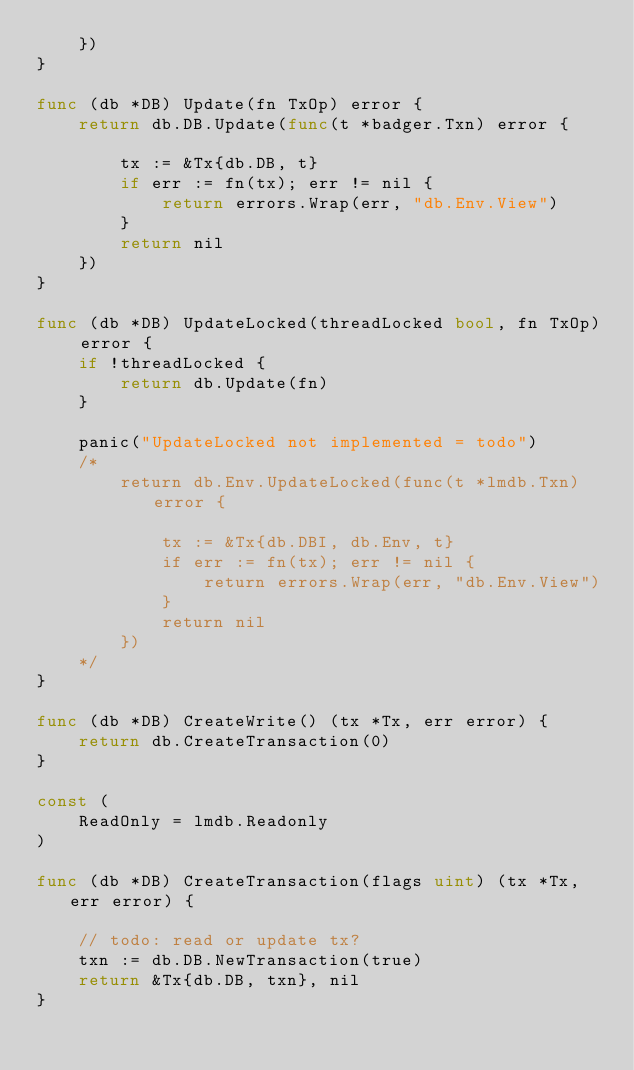<code> <loc_0><loc_0><loc_500><loc_500><_Go_>	})
}

func (db *DB) Update(fn TxOp) error {
	return db.DB.Update(func(t *badger.Txn) error {

		tx := &Tx{db.DB, t}
		if err := fn(tx); err != nil {
			return errors.Wrap(err, "db.Env.View")
		}
		return nil
	})
}

func (db *DB) UpdateLocked(threadLocked bool, fn TxOp) error {
	if !threadLocked {
		return db.Update(fn)
	}

	panic("UpdateLocked not implemented = todo")
	/*
		return db.Env.UpdateLocked(func(t *lmdb.Txn) error {

			tx := &Tx{db.DBI, db.Env, t}
			if err := fn(tx); err != nil {
				return errors.Wrap(err, "db.Env.View")
			}
			return nil
		})
	*/
}

func (db *DB) CreateWrite() (tx *Tx, err error) {
	return db.CreateTransaction(0)
}

const (
	ReadOnly = lmdb.Readonly
)

func (db *DB) CreateTransaction(flags uint) (tx *Tx, err error) {

	// todo: read or update tx?
	txn := db.DB.NewTransaction(true)
	return &Tx{db.DB, txn}, nil
}
</code> 